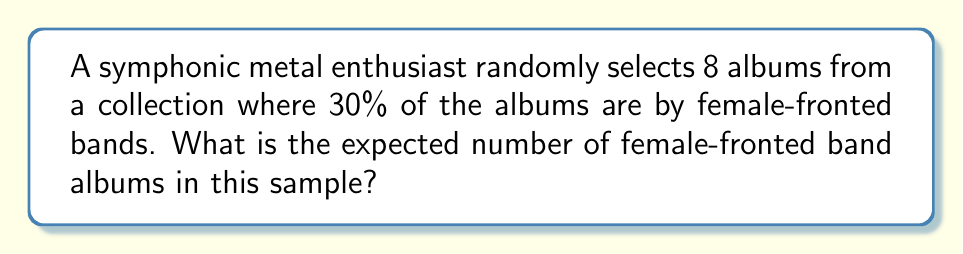Could you help me with this problem? Let's approach this step-by-step:

1) First, we need to identify the random variable. Let $X$ be the number of female-fronted band albums in the sample.

2) This scenario follows a binomial distribution because:
   - There are a fixed number of trials (8 album selections)
   - Each trial has two possible outcomes (female-fronted or not)
   - The probability of success (selecting a female-fronted band album) is constant for each trial
   - The trials are independent

3) For a binomial distribution, the expected value is given by:

   $$E(X) = np$$

   Where:
   $n$ = number of trials
   $p$ = probability of success on each trial

4) In this case:
   $n = 8$ (number of albums selected)
   $p = 0.30$ (30% of albums are by female-fronted bands)

5) Plugging these values into the formula:

   $$E(X) = 8 \times 0.30 = 2.4$$

Therefore, the expected number of female-fronted band albums in the sample is 2.4.
Answer: 2.4 